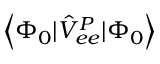<formula> <loc_0><loc_0><loc_500><loc_500>\left < \Phi _ { 0 } | \hat { V } _ { e e } ^ { P } | \Phi _ { 0 } \right ></formula> 